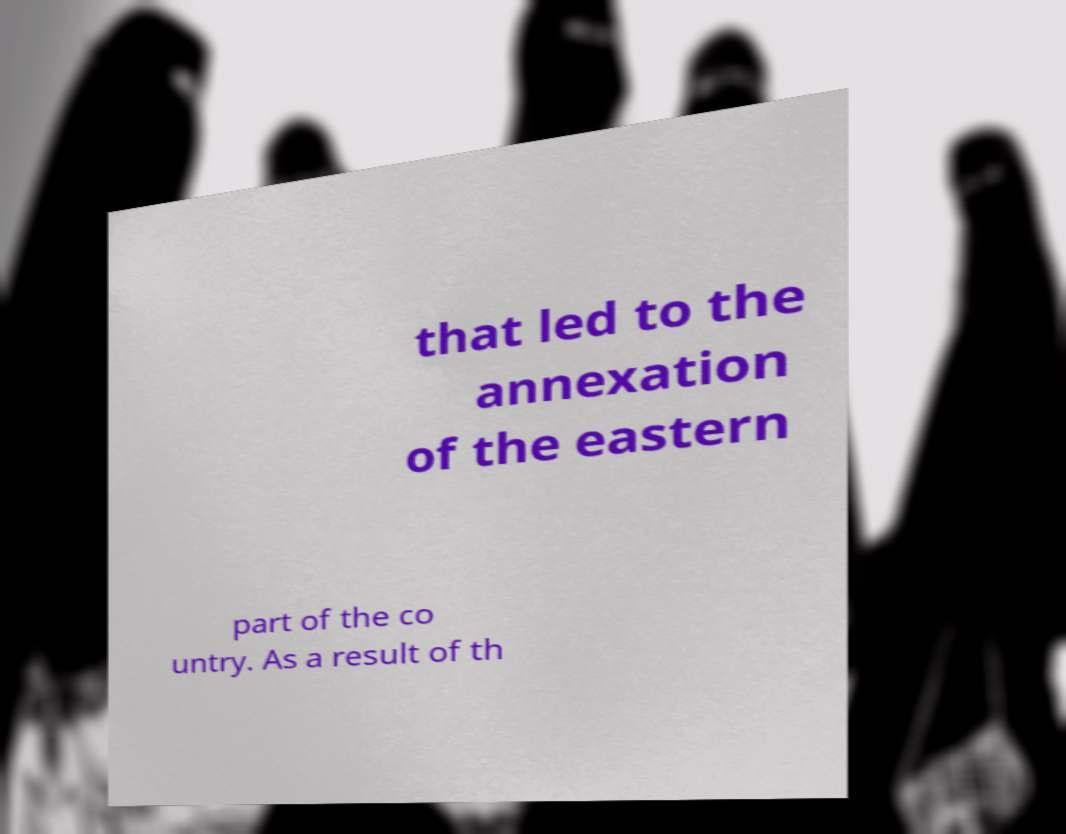Could you assist in decoding the text presented in this image and type it out clearly? that led to the annexation of the eastern part of the co untry. As a result of th 